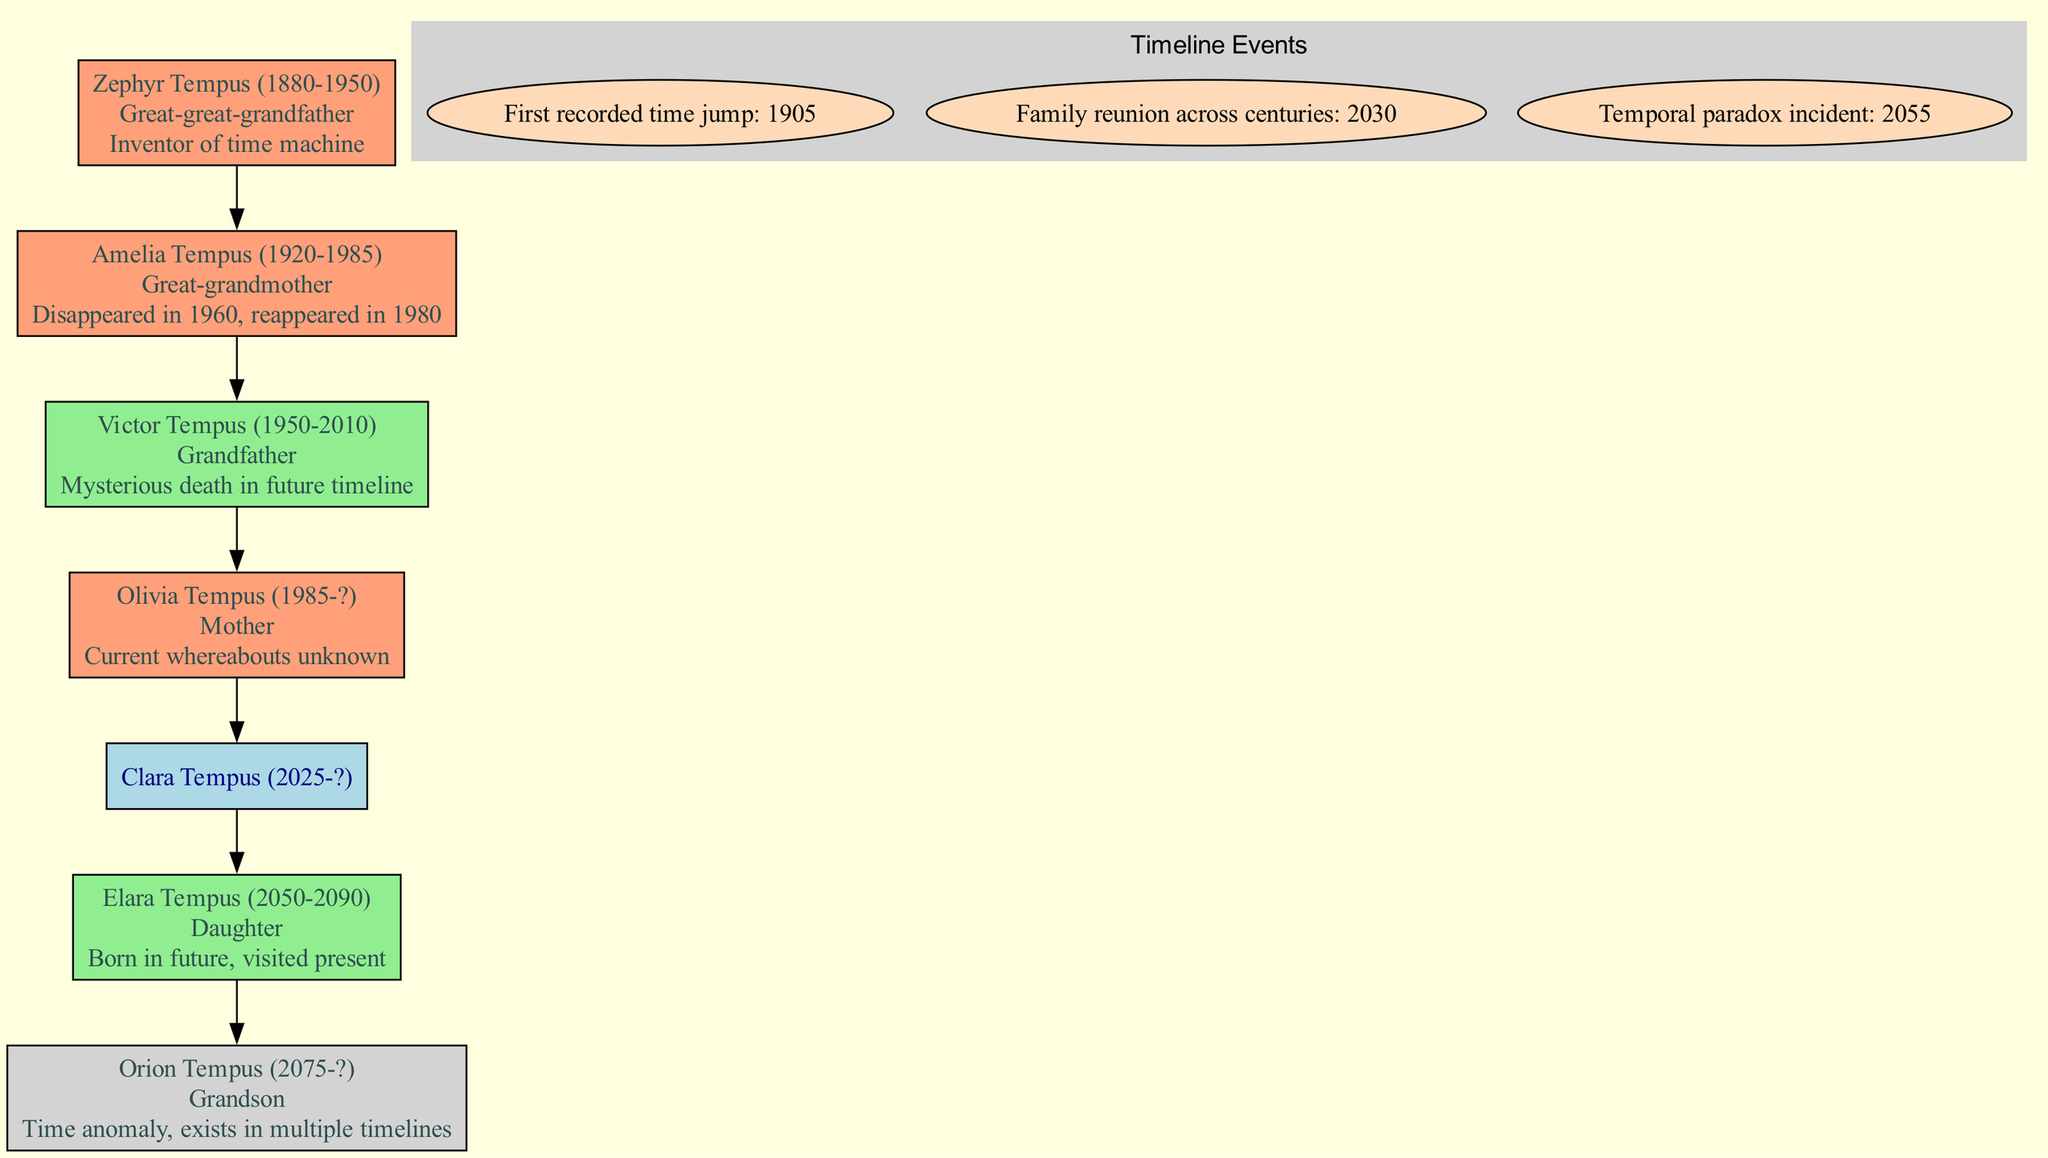What is the name of the root person in the family tree? The root person, represented at the top of the diagram, is Clara Tempus, as identified in the data provided.
Answer: Clara Tempus Who is the great-great-grandfather of Clara Tempus? According to the family members listed, Zephyr Tempus is identified as Clara's great-great-grandfather, establishing his relationship within the family tree.
Answer: Zephyr Tempus How many family members are depicted in the diagram? Counting the number of family members provided in the data reveals a total of six members, which includes Clara as the root person.
Answer: 6 What year did Amelia Tempus disappear? The note attached to Amelia Tempus indicates that she disappeared in 1960, clearly stating the year of her mysterious absence.
Answer: 1960 Which family member has a note indicating a mysterious death? The note associated with Victor Tempus specifies a "mysterious death in future timeline," indicating that he is the family member with this detail.
Answer: Victor Tempus How many timeline events are included in the chart? The timeline events indicated in the data list three significant occurrences, reflecting the family's history of time travel.
Answer: 3 What relationship does Orion Tempus have to Clara Tempus? Orion Tempus is listed as the grandson of Clara Tempus in the family relationships, making this the established connection.
Answer: Grandson Which family member was born in the future? Elara Tempus is specifically noted as being born in 2050, indicating her birth timeline is in the future relative to the chart's present.
Answer: Elara Tempus What is the main event that occurs in 2030 according to the timeline? The event that takes place in 2030 is a family reunion across centuries, suggesting it is a significant gathering for the family tree.
Answer: Family reunion across centuries 